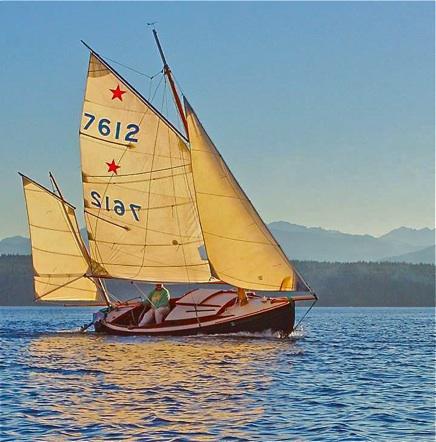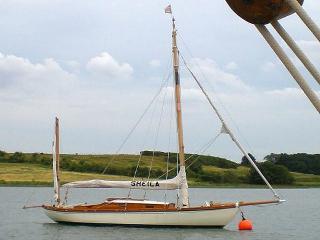The first image is the image on the left, the second image is the image on the right. Evaluate the accuracy of this statement regarding the images: "The sails in the left image are closed.". Is it true? Answer yes or no. No. The first image is the image on the left, the second image is the image on the right. For the images shown, is this caption "The left and right image contains the same number sailboats with at least one boat with its sails down." true? Answer yes or no. Yes. 